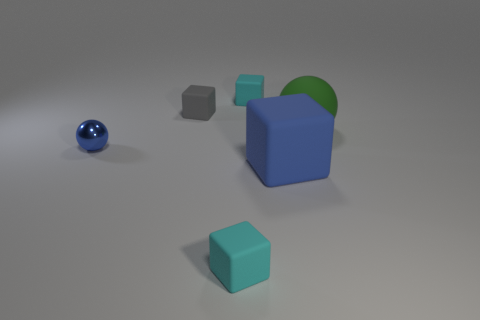Subtract all purple cylinders. How many cyan blocks are left? 2 Subtract all big blue matte blocks. How many blocks are left? 3 Subtract all blue cubes. How many cubes are left? 3 Add 1 big yellow metallic cylinders. How many objects exist? 7 Subtract 2 blocks. How many blocks are left? 2 Subtract all cubes. How many objects are left? 2 Subtract 0 brown spheres. How many objects are left? 6 Subtract all blue cubes. Subtract all cyan cylinders. How many cubes are left? 3 Subtract all rubber blocks. Subtract all tiny metallic objects. How many objects are left? 1 Add 2 large rubber balls. How many large rubber balls are left? 3 